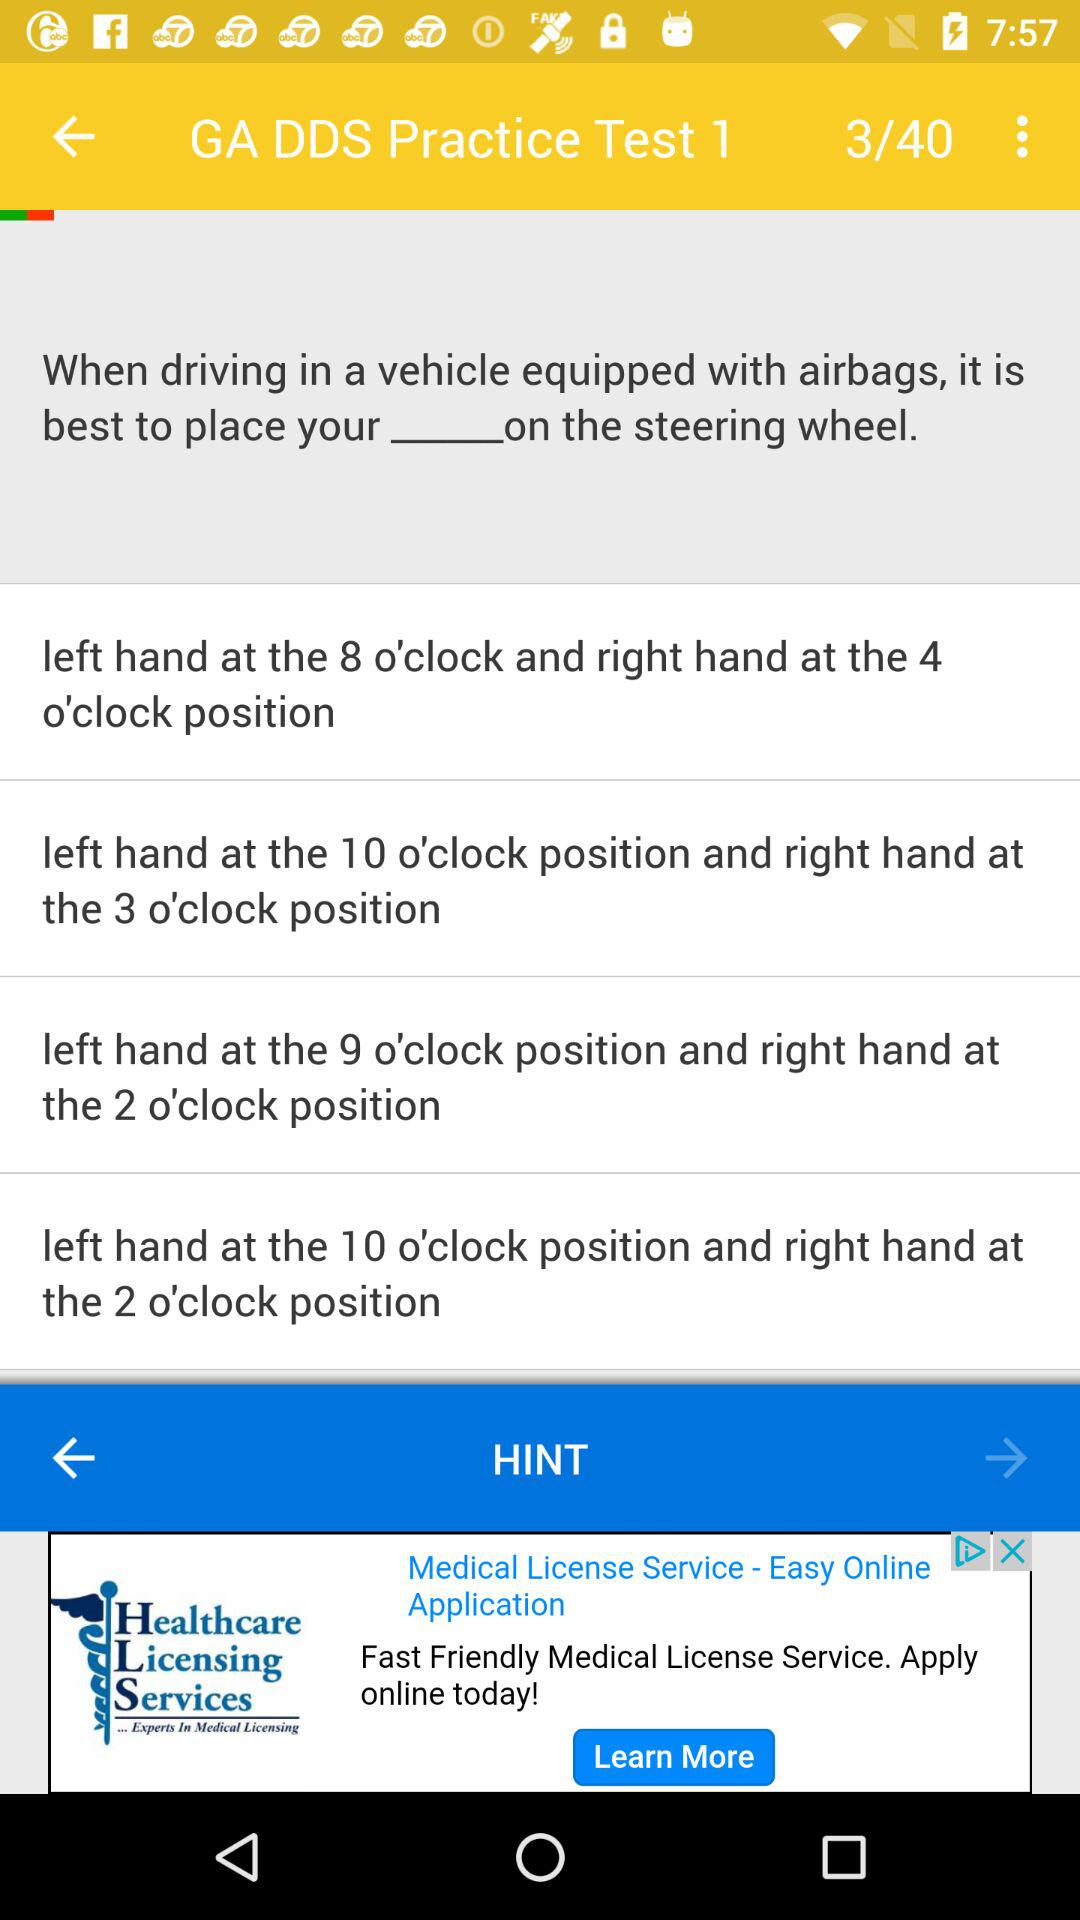How many hands are mentioned in the text?
Answer the question using a single word or phrase. 2 